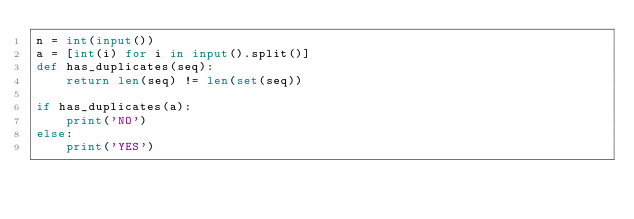Convert code to text. <code><loc_0><loc_0><loc_500><loc_500><_Python_>n = int(input())
a = [int(i) for i in input().split()]
def has_duplicates(seq):
    return len(seq) != len(set(seq))

if has_duplicates(a):
    print('NO')
else:
    print('YES')</code> 